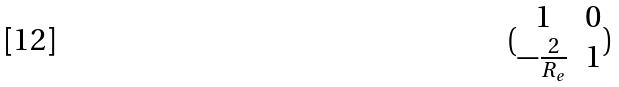Convert formula to latex. <formula><loc_0><loc_0><loc_500><loc_500>( \begin{matrix} 1 & 0 \\ - \frac { 2 } { R _ { e } } & 1 \end{matrix} )</formula> 